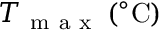<formula> <loc_0><loc_0><loc_500><loc_500>T _ { m a x } \, ( ^ { \circ } C )</formula> 